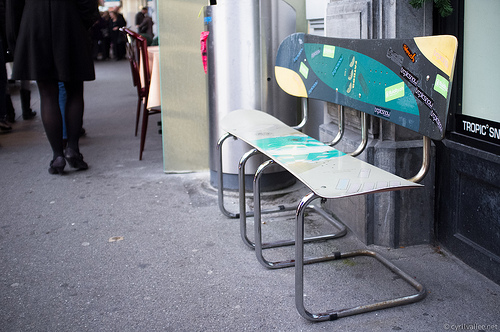<image>
Can you confirm if the sign is to the right of the chair? Yes. From this viewpoint, the sign is positioned to the right side relative to the chair. 